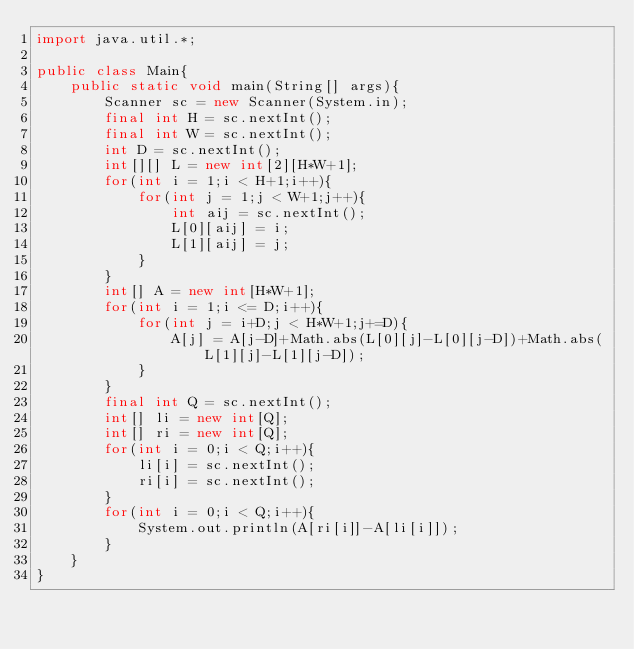Convert code to text. <code><loc_0><loc_0><loc_500><loc_500><_Java_>import java.util.*;

public class Main{
    public static void main(String[] args){
        Scanner sc = new Scanner(System.in);
        final int H = sc.nextInt();
        final int W = sc.nextInt();
        int D = sc.nextInt();
        int[][] L = new int[2][H*W+1];
        for(int i = 1;i < H+1;i++){
            for(int j = 1;j < W+1;j++){
                int aij = sc.nextInt();
                L[0][aij] = i;
                L[1][aij] = j;
            }
        }
        int[] A = new int[H*W+1];
        for(int i = 1;i <= D;i++){
            for(int j = i+D;j < H*W+1;j+=D){
                A[j] = A[j-D]+Math.abs(L[0][j]-L[0][j-D])+Math.abs(L[1][j]-L[1][j-D]);
            }
        }
        final int Q = sc.nextInt();
        int[] li = new int[Q];
        int[] ri = new int[Q];
        for(int i = 0;i < Q;i++){
            li[i] = sc.nextInt();
            ri[i] = sc.nextInt();
        }
        for(int i = 0;i < Q;i++){
            System.out.println(A[ri[i]]-A[li[i]]);
        }
    }
}</code> 